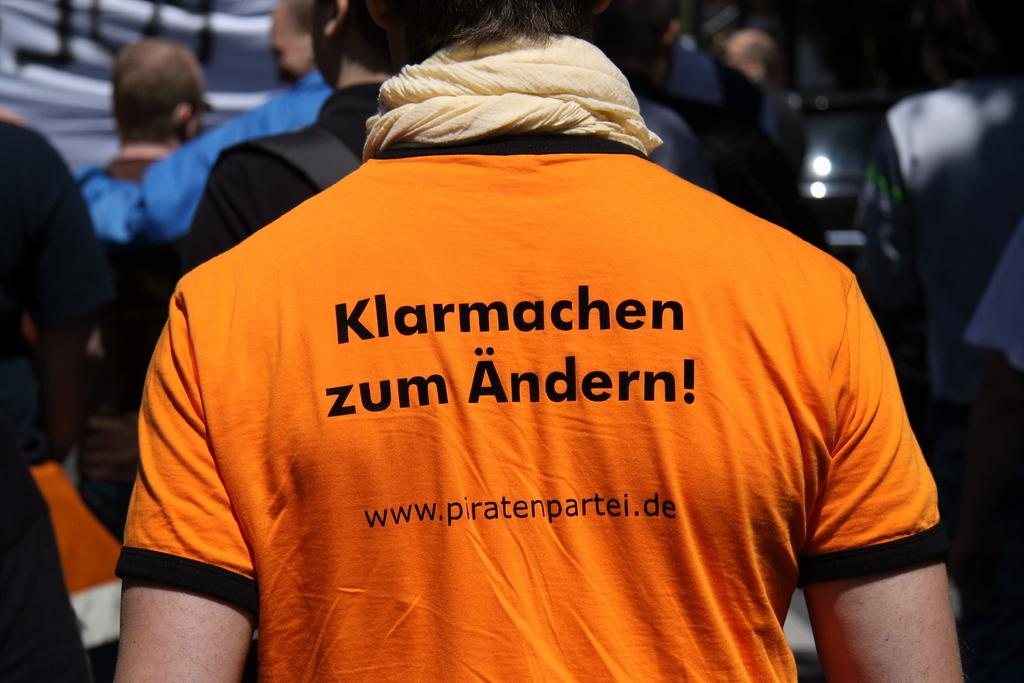<image>
Create a compact narrative representing the image presented. back of someone wearing orange shirt with klarmachen zum andern! on it 